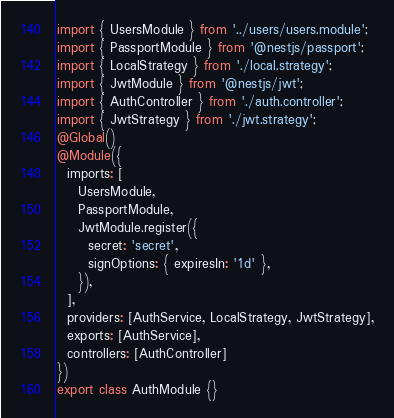<code> <loc_0><loc_0><loc_500><loc_500><_TypeScript_>import { UsersModule } from '../users/users.module';
import { PassportModule } from '@nestjs/passport';
import { LocalStrategy } from './local.strategy';
import { JwtModule } from '@nestjs/jwt';
import { AuthController } from './auth.controller';
import { JwtStrategy } from './jwt.strategy';
@Global()
@Module({
  imports: [
    UsersModule,
    PassportModule,
    JwtModule.register({
      secret: 'secret',
      signOptions: { expiresIn: '1d' },
    }),
  ],
  providers: [AuthService, LocalStrategy, JwtStrategy],
  exports: [AuthService],
  controllers: [AuthController]
})
export class AuthModule {}
</code> 